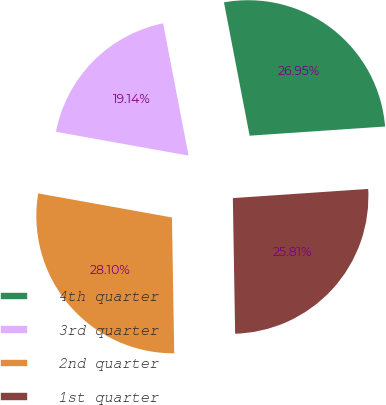Convert chart. <chart><loc_0><loc_0><loc_500><loc_500><pie_chart><fcel>4th quarter<fcel>3rd quarter<fcel>2nd quarter<fcel>1st quarter<nl><fcel>26.95%<fcel>19.14%<fcel>28.1%<fcel>25.81%<nl></chart> 